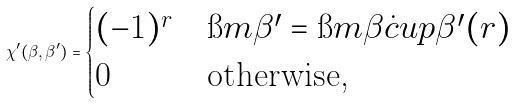<formula> <loc_0><loc_0><loc_500><loc_500>\chi ^ { \prime } ( \beta , \beta ^ { \prime } ) = \begin{cases} ( - 1 ) ^ { r } & \i m \beta ^ { \prime } = \i m \beta \dot { c } u p { \beta ^ { \prime } ( r ) } \\ 0 & \text {otherwise,} \end{cases}</formula> 